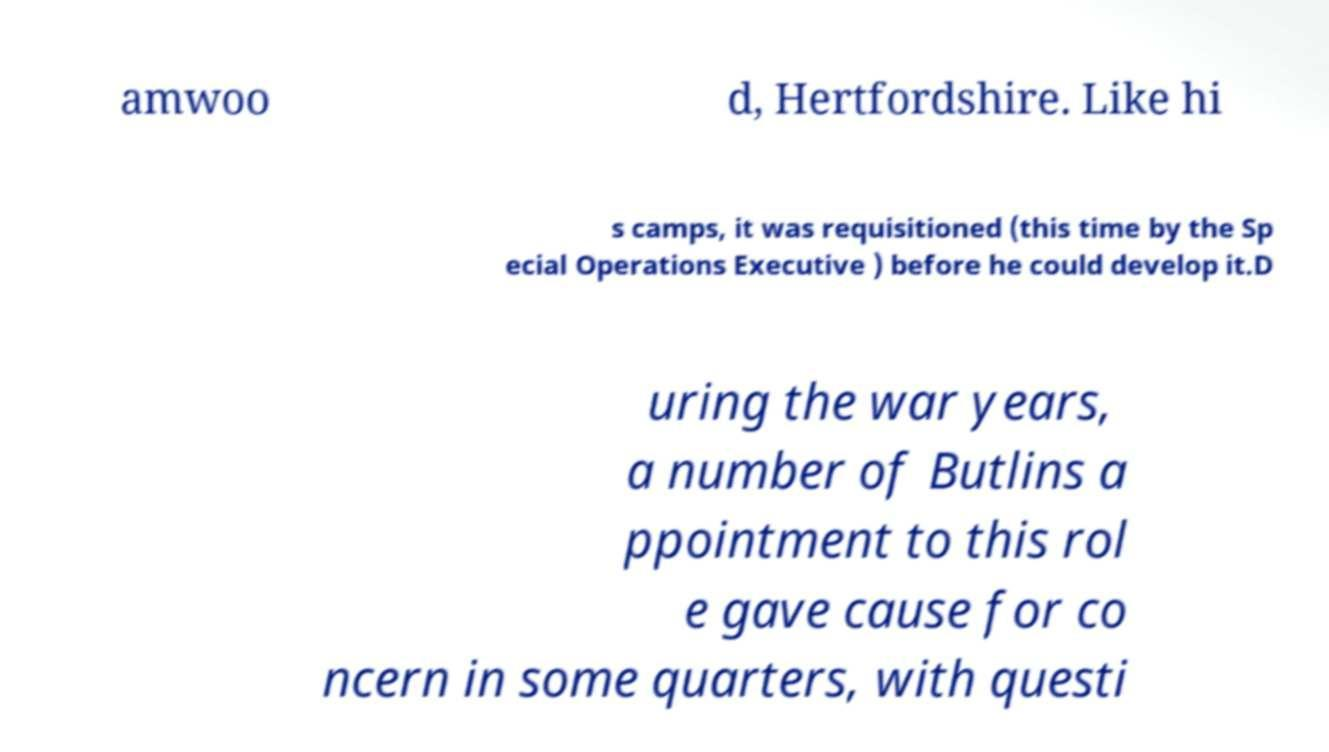Can you read and provide the text displayed in the image?This photo seems to have some interesting text. Can you extract and type it out for me? amwoo d, Hertfordshire. Like hi s camps, it was requisitioned (this time by the Sp ecial Operations Executive ) before he could develop it.D uring the war years, a number of Butlins a ppointment to this rol e gave cause for co ncern in some quarters, with questi 